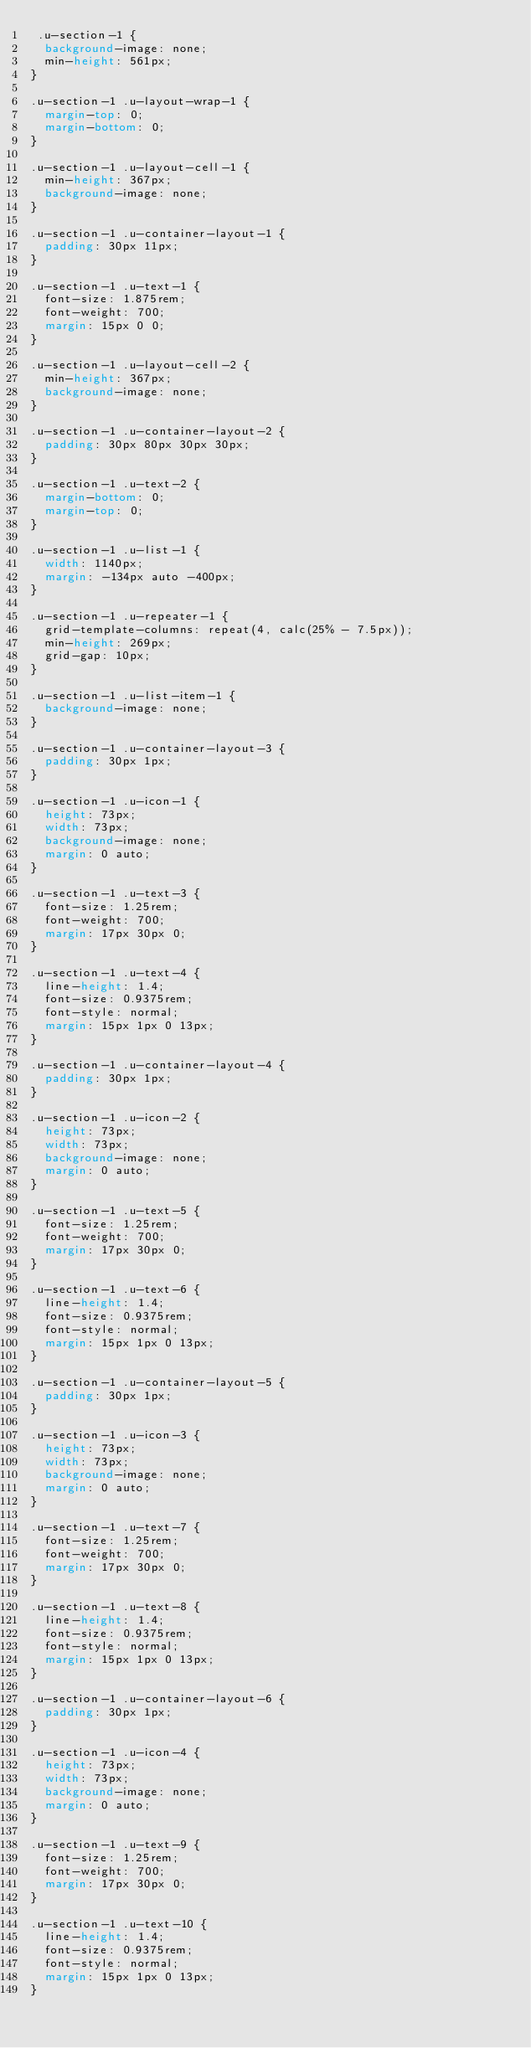Convert code to text. <code><loc_0><loc_0><loc_500><loc_500><_CSS_> .u-section-1 {
  background-image: none;
  min-height: 561px;
}

.u-section-1 .u-layout-wrap-1 {
  margin-top: 0;
  margin-bottom: 0;
}

.u-section-1 .u-layout-cell-1 {
  min-height: 367px;
  background-image: none;
}

.u-section-1 .u-container-layout-1 {
  padding: 30px 11px;
}

.u-section-1 .u-text-1 {
  font-size: 1.875rem;
  font-weight: 700;
  margin: 15px 0 0;
}

.u-section-1 .u-layout-cell-2 {
  min-height: 367px;
  background-image: none;
}

.u-section-1 .u-container-layout-2 {
  padding: 30px 80px 30px 30px;
}

.u-section-1 .u-text-2 {
  margin-bottom: 0;
  margin-top: 0;
}

.u-section-1 .u-list-1 {
  width: 1140px;
  margin: -134px auto -400px;
}

.u-section-1 .u-repeater-1 {
  grid-template-columns: repeat(4, calc(25% - 7.5px));
  min-height: 269px;
  grid-gap: 10px;
}

.u-section-1 .u-list-item-1 {
  background-image: none;
}

.u-section-1 .u-container-layout-3 {
  padding: 30px 1px;
}

.u-section-1 .u-icon-1 {
  height: 73px;
  width: 73px;
  background-image: none;
  margin: 0 auto;
}

.u-section-1 .u-text-3 {
  font-size: 1.25rem;
  font-weight: 700;
  margin: 17px 30px 0;
}

.u-section-1 .u-text-4 {
  line-height: 1.4;
  font-size: 0.9375rem;
  font-style: normal;
  margin: 15px 1px 0 13px;
}

.u-section-1 .u-container-layout-4 {
  padding: 30px 1px;
}

.u-section-1 .u-icon-2 {
  height: 73px;
  width: 73px;
  background-image: none;
  margin: 0 auto;
}

.u-section-1 .u-text-5 {
  font-size: 1.25rem;
  font-weight: 700;
  margin: 17px 30px 0;
}

.u-section-1 .u-text-6 {
  line-height: 1.4;
  font-size: 0.9375rem;
  font-style: normal;
  margin: 15px 1px 0 13px;
}

.u-section-1 .u-container-layout-5 {
  padding: 30px 1px;
}

.u-section-1 .u-icon-3 {
  height: 73px;
  width: 73px;
  background-image: none;
  margin: 0 auto;
}

.u-section-1 .u-text-7 {
  font-size: 1.25rem;
  font-weight: 700;
  margin: 17px 30px 0;
}

.u-section-1 .u-text-8 {
  line-height: 1.4;
  font-size: 0.9375rem;
  font-style: normal;
  margin: 15px 1px 0 13px;
}

.u-section-1 .u-container-layout-6 {
  padding: 30px 1px;
}

.u-section-1 .u-icon-4 {
  height: 73px;
  width: 73px;
  background-image: none;
  margin: 0 auto;
}

.u-section-1 .u-text-9 {
  font-size: 1.25rem;
  font-weight: 700;
  margin: 17px 30px 0;
}

.u-section-1 .u-text-10 {
  line-height: 1.4;
  font-size: 0.9375rem;
  font-style: normal;
  margin: 15px 1px 0 13px;
}
</code> 